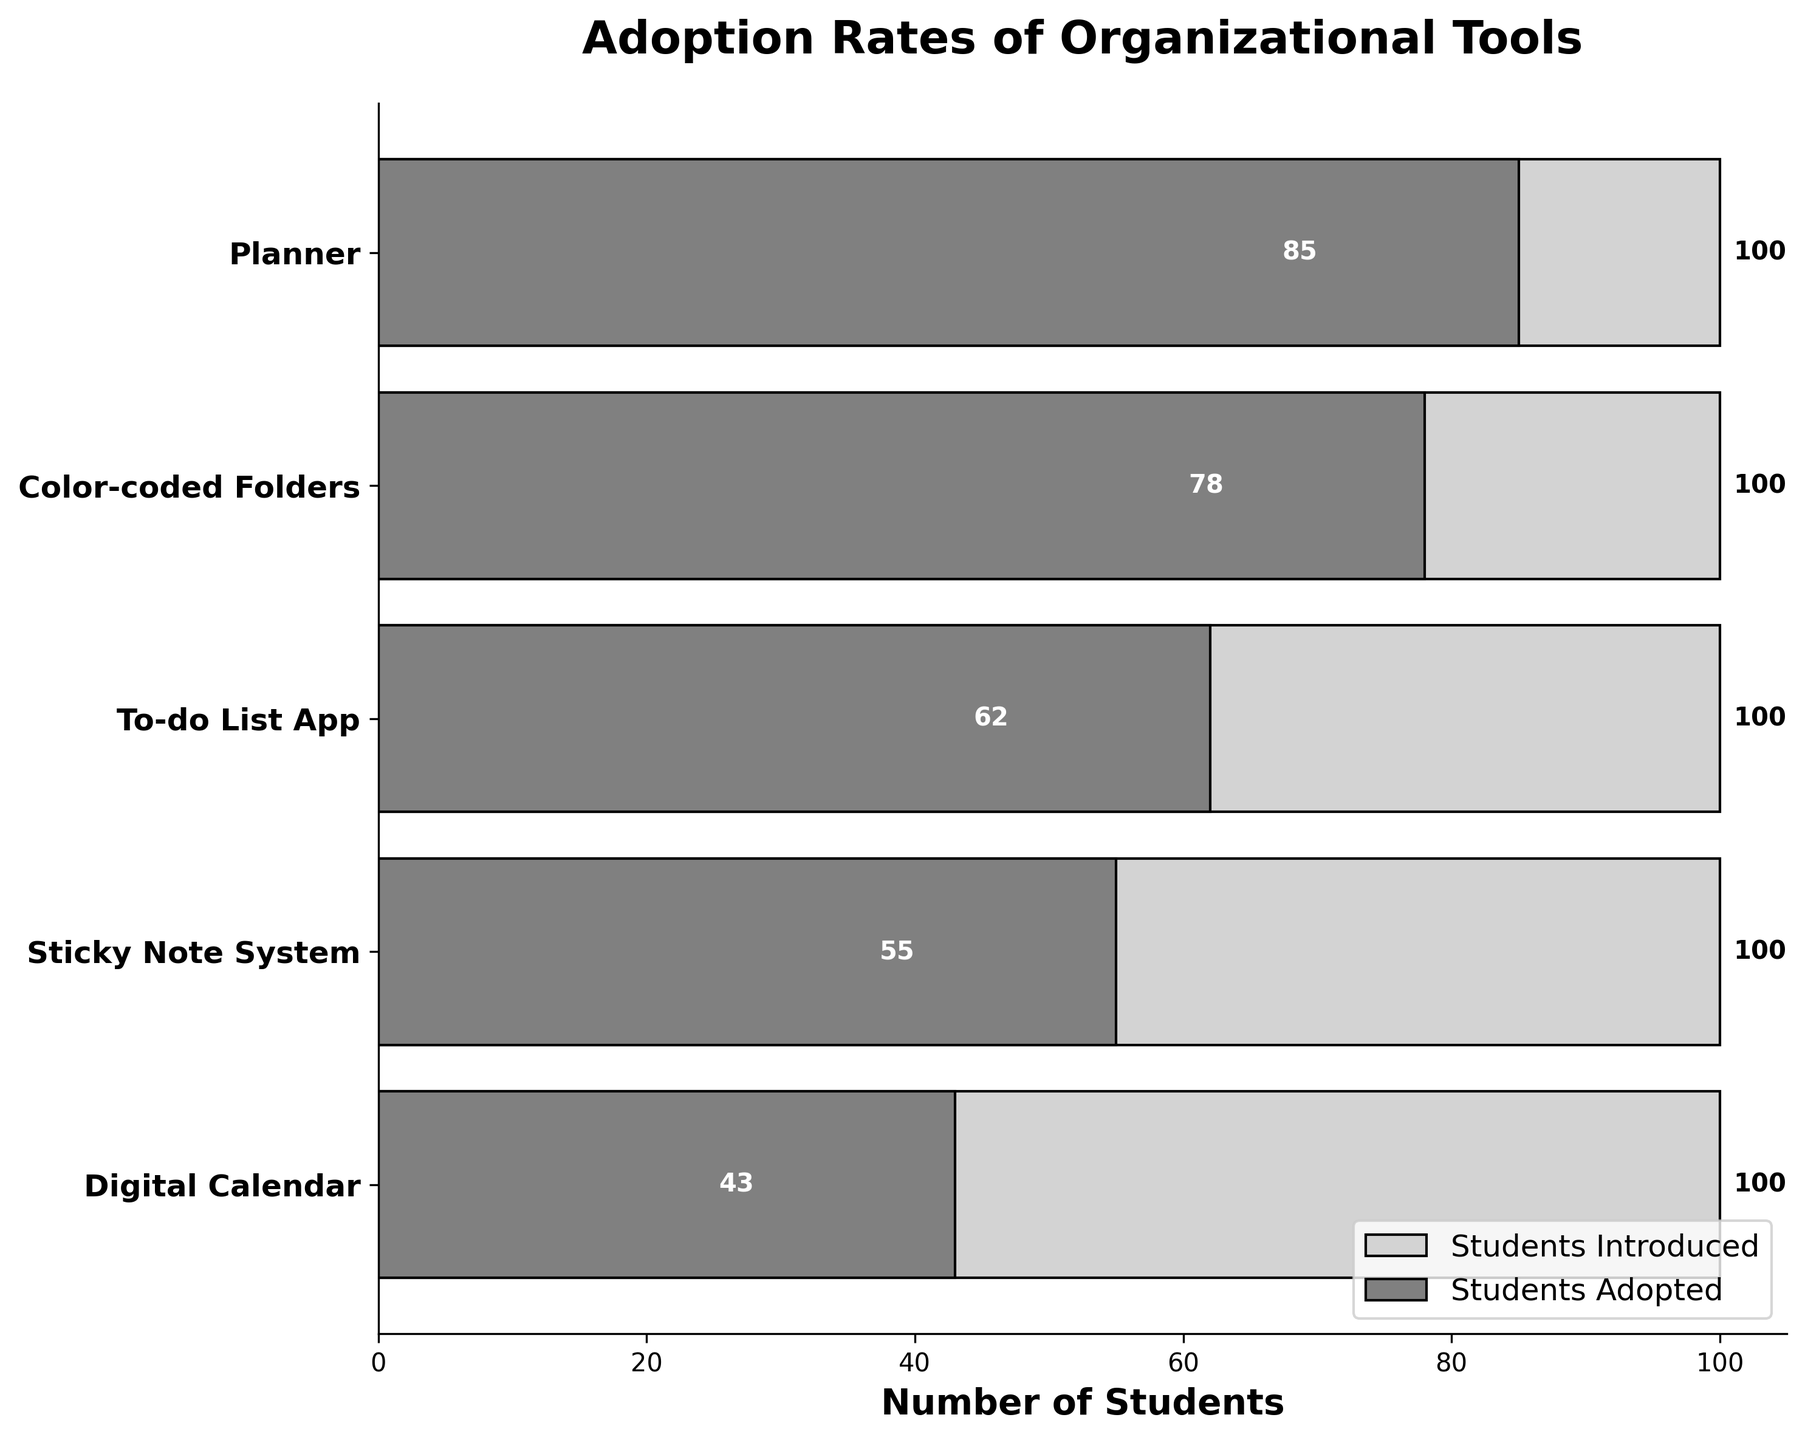Which organizational tool had the highest adoption rate? The figure shows the adoption rates for different organizational tools. By comparing the lengths of the "Students Adopted" bars, we see that the Planner has the highest adoption rate.
Answer: Planner Which organizational tool had the lowest adoption rate? To find the tool with the lowest adoption rate, we compare the lengths of the "Students Adopted" bars. The Digital Calendar has the shortest bar, indicating the lowest adoption rate.
Answer: Digital Calendar How many more students adopted color-coded folders compared to the sticky note system? Comparing the "Students Adopted" bars for Color-coded Folders (78) and Sticky Note System (55), we calculate the difference: 78 - 55 = 23.
Answer: 23 What is the total number of students who adopted any organizational tool? To find the total, sum the "Students Adopted" values for all tools: 85 + 78 + 62 + 55 + 43 = 323.
Answer: 323 What is the average number of students who adopted the organizational tools? Calculate the average by summing the "Students Adopted" values and dividing by the number of tools: (85 + 78 + 62 + 55 + 43) / 5 = 323 / 5 = 64.6.
Answer: 64.6 Which two tools have the most similar adoption rates? Comparing "Students Adopted" bars, the To-do List App (62) and the Sticky Note System (55) have the closest values, with a difference of 7.
Answer: To-do List App and Sticky Note System By how much does the adoption rate of the Planner exceed that of the Digital Calendar? Compare the "Students Adopted" values: Planner (85) and Digital Calendar (43), computing the difference: 85 - 43 = 42.
Answer: 42 What percentage of students adopted the Color-coded Folders out of the total students introduced to it? Calculate the percentage: (78 / 100) * 100% = 78%.
Answer: 78% Rank the tools from highest to lowest adoption rates. Based on the "Students Adopted" values: Planner (85), Color-coded Folders (78), To-do List App (62), Sticky Note System (55), Digital Calendar (43).
Answer: Planner, Color-coded Folders, To-do List App, Sticky Note System, Digital Calendar How much greater is the adoption rate of the Planner compared to the average adoption rate of all tools? First, calculate the average adoption rate (64.6). Then, compare the Planner's adopted value (85): 85 - 64.6 = 20.4.
Answer: 20.4 